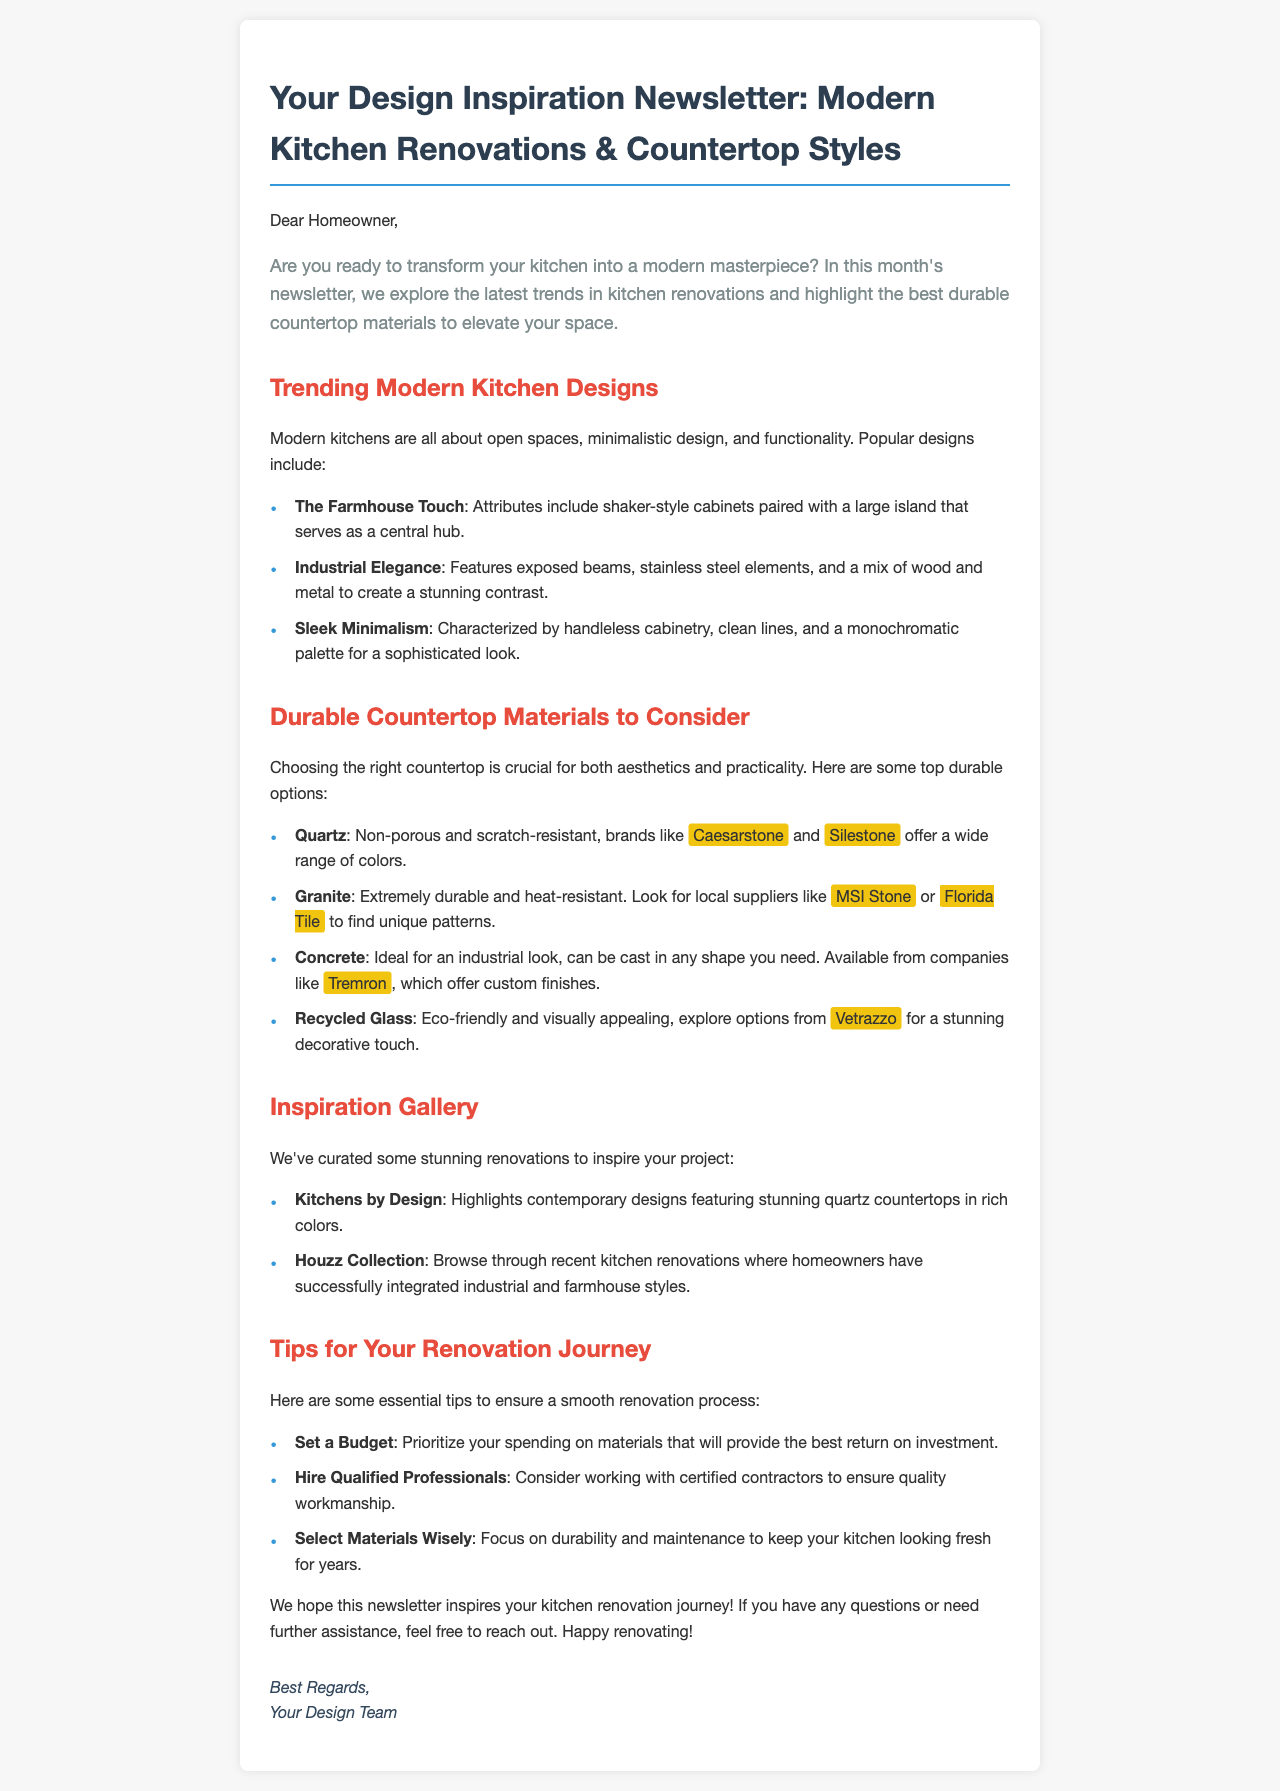What are the three popular modern kitchen designs mentioned? The document lists three popular modern kitchen designs: The Farmhouse Touch, Industrial Elegance, and Sleek Minimalism.
Answer: The Farmhouse Touch, Industrial Elegance, Sleek Minimalism Which countertop material is described as eco-friendly? The document states that Recycled Glass is an eco-friendly option.
Answer: Recycled Glass What is a key feature of the Industrial Elegance design? The document describes exposed beams, stainless steel elements, and a mix of wood and metal as features of Industrial Elegance.
Answer: Exposed beams What is suggested to prioritize when setting a budget? The document suggests prioritizing spending on materials that provide the best return on investment.
Answer: Materials that provide the best return on investment Which company offers custom finishes for concrete countertops? The document provides information that Tremron offers custom finishes for concrete countertops.
Answer: Tremron How many tips are provided for the renovation journey? The document lists three essential tips for a smooth renovation process.
Answer: Three What type of designs does the Kitchens by Design collection focus on? The document mentions that Kitchens by Design showcases contemporary designs featuring quartz countertops.
Answer: Contemporary designs What is the color of the heading for the "Durable Countertop Materials to Consider" section? The document states that the heading color for this section is red, as denoted by its style.
Answer: Red 